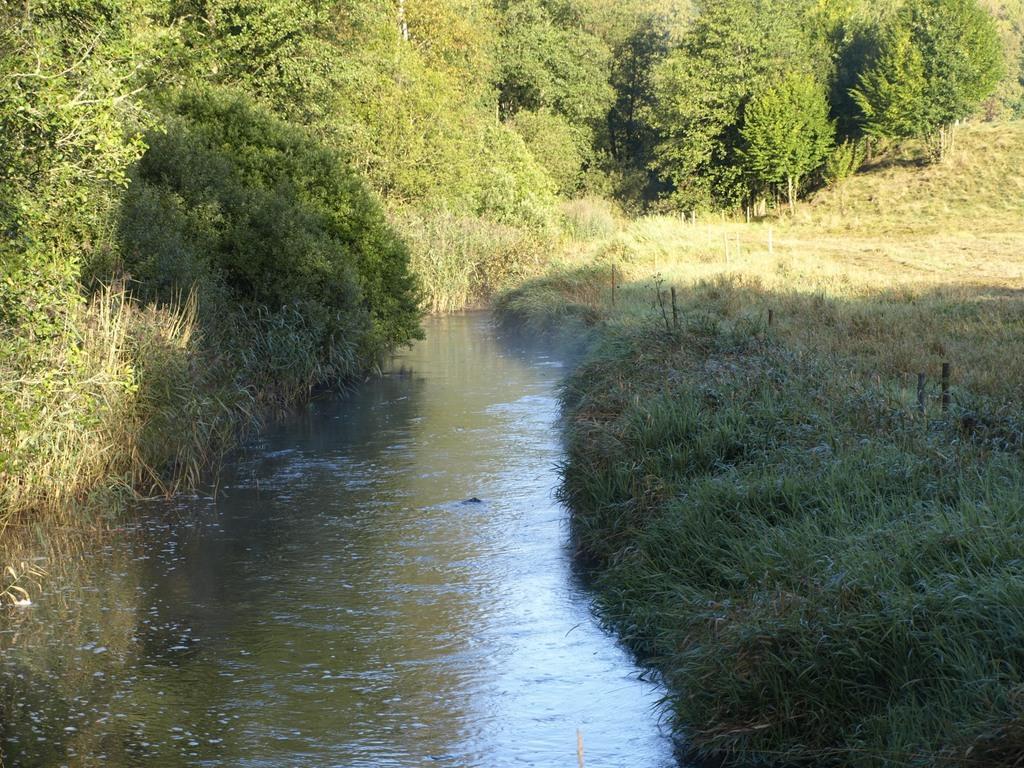Describe this image in one or two sentences. In this picture I can see many trees, plants and grass. At the bottom I can see the water flow. 